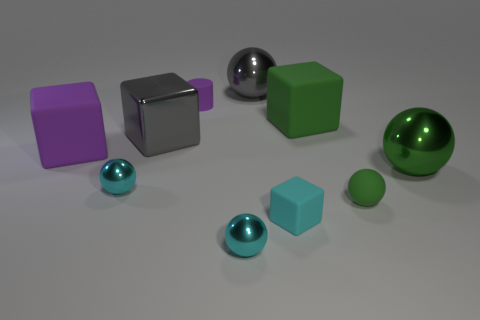Subtract all cyan spheres. How many spheres are left? 3 Subtract all gray cubes. How many green balls are left? 2 Subtract all green balls. How many balls are left? 3 Subtract all cylinders. How many objects are left? 9 Subtract 2 blocks. How many blocks are left? 2 Add 7 purple cubes. How many purple cubes exist? 8 Subtract 0 blue cylinders. How many objects are left? 10 Subtract all gray blocks. Subtract all brown cylinders. How many blocks are left? 3 Subtract all big purple matte things. Subtract all big red balls. How many objects are left? 9 Add 1 tiny green matte spheres. How many tiny green matte spheres are left? 2 